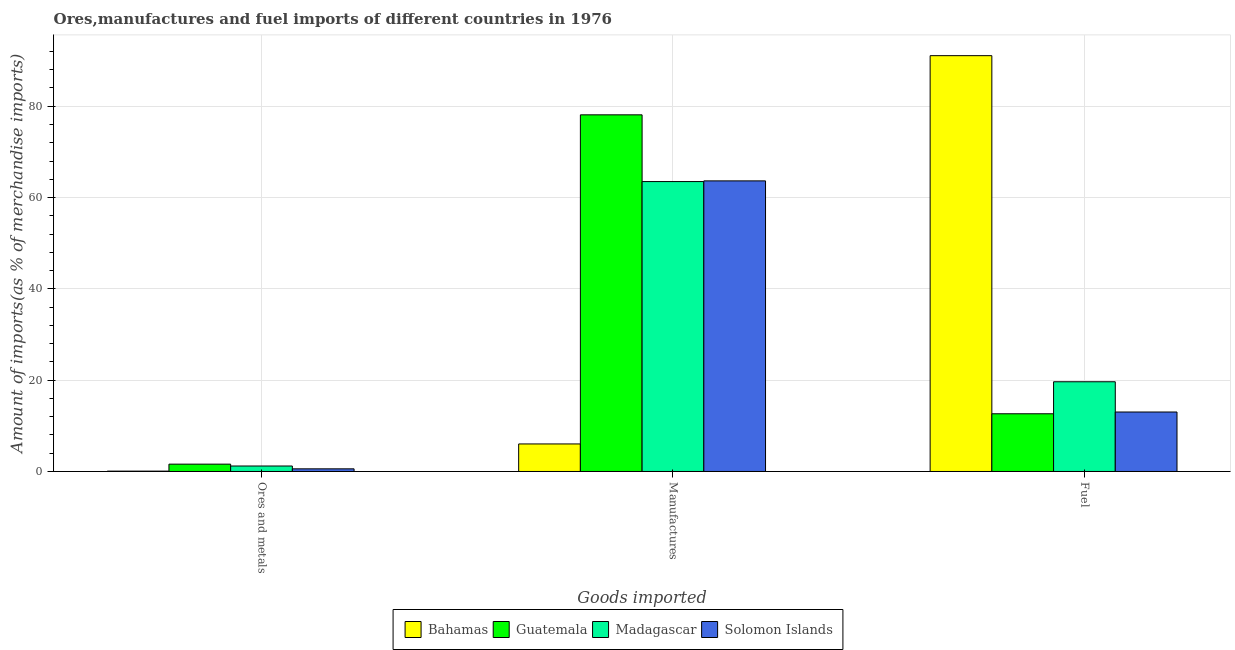How many groups of bars are there?
Make the answer very short. 3. Are the number of bars on each tick of the X-axis equal?
Your answer should be compact. Yes. What is the label of the 3rd group of bars from the left?
Make the answer very short. Fuel. What is the percentage of ores and metals imports in Solomon Islands?
Offer a terse response. 0.58. Across all countries, what is the maximum percentage of ores and metals imports?
Provide a succinct answer. 1.61. Across all countries, what is the minimum percentage of ores and metals imports?
Offer a terse response. 0.08. In which country was the percentage of ores and metals imports maximum?
Keep it short and to the point. Guatemala. In which country was the percentage of ores and metals imports minimum?
Give a very brief answer. Bahamas. What is the total percentage of ores and metals imports in the graph?
Make the answer very short. 3.46. What is the difference between the percentage of manufactures imports in Madagascar and that in Bahamas?
Provide a succinct answer. 57.47. What is the difference between the percentage of manufactures imports in Bahamas and the percentage of ores and metals imports in Madagascar?
Offer a terse response. 4.83. What is the average percentage of fuel imports per country?
Ensure brevity in your answer.  34.1. What is the difference between the percentage of ores and metals imports and percentage of manufactures imports in Guatemala?
Your response must be concise. -76.51. What is the ratio of the percentage of ores and metals imports in Guatemala to that in Madagascar?
Your response must be concise. 1.34. What is the difference between the highest and the second highest percentage of fuel imports?
Your response must be concise. 71.43. What is the difference between the highest and the lowest percentage of fuel imports?
Offer a terse response. 78.44. Is the sum of the percentage of ores and metals imports in Solomon Islands and Madagascar greater than the maximum percentage of manufactures imports across all countries?
Make the answer very short. No. What does the 2nd bar from the left in Manufactures represents?
Your answer should be compact. Guatemala. What does the 2nd bar from the right in Fuel represents?
Give a very brief answer. Madagascar. Is it the case that in every country, the sum of the percentage of ores and metals imports and percentage of manufactures imports is greater than the percentage of fuel imports?
Your response must be concise. No. How many bars are there?
Keep it short and to the point. 12. Are the values on the major ticks of Y-axis written in scientific E-notation?
Your answer should be very brief. No. Does the graph contain any zero values?
Provide a short and direct response. No. Where does the legend appear in the graph?
Give a very brief answer. Bottom center. How are the legend labels stacked?
Provide a short and direct response. Horizontal. What is the title of the graph?
Make the answer very short. Ores,manufactures and fuel imports of different countries in 1976. Does "Gabon" appear as one of the legend labels in the graph?
Make the answer very short. No. What is the label or title of the X-axis?
Keep it short and to the point. Goods imported. What is the label or title of the Y-axis?
Offer a very short reply. Amount of imports(as % of merchandise imports). What is the Amount of imports(as % of merchandise imports) in Bahamas in Ores and metals?
Provide a short and direct response. 0.08. What is the Amount of imports(as % of merchandise imports) of Guatemala in Ores and metals?
Give a very brief answer. 1.61. What is the Amount of imports(as % of merchandise imports) of Madagascar in Ores and metals?
Make the answer very short. 1.2. What is the Amount of imports(as % of merchandise imports) of Solomon Islands in Ores and metals?
Your answer should be very brief. 0.58. What is the Amount of imports(as % of merchandise imports) of Bahamas in Manufactures?
Keep it short and to the point. 6.03. What is the Amount of imports(as % of merchandise imports) in Guatemala in Manufactures?
Provide a succinct answer. 78.12. What is the Amount of imports(as % of merchandise imports) of Madagascar in Manufactures?
Make the answer very short. 63.5. What is the Amount of imports(as % of merchandise imports) of Solomon Islands in Manufactures?
Your answer should be very brief. 63.65. What is the Amount of imports(as % of merchandise imports) in Bahamas in Fuel?
Your response must be concise. 91.08. What is the Amount of imports(as % of merchandise imports) of Guatemala in Fuel?
Provide a short and direct response. 12.64. What is the Amount of imports(as % of merchandise imports) in Madagascar in Fuel?
Make the answer very short. 19.65. What is the Amount of imports(as % of merchandise imports) of Solomon Islands in Fuel?
Your answer should be very brief. 13.03. Across all Goods imported, what is the maximum Amount of imports(as % of merchandise imports) in Bahamas?
Your answer should be compact. 91.08. Across all Goods imported, what is the maximum Amount of imports(as % of merchandise imports) of Guatemala?
Keep it short and to the point. 78.12. Across all Goods imported, what is the maximum Amount of imports(as % of merchandise imports) of Madagascar?
Your response must be concise. 63.5. Across all Goods imported, what is the maximum Amount of imports(as % of merchandise imports) of Solomon Islands?
Offer a terse response. 63.65. Across all Goods imported, what is the minimum Amount of imports(as % of merchandise imports) of Bahamas?
Keep it short and to the point. 0.08. Across all Goods imported, what is the minimum Amount of imports(as % of merchandise imports) in Guatemala?
Offer a terse response. 1.61. Across all Goods imported, what is the minimum Amount of imports(as % of merchandise imports) of Madagascar?
Provide a short and direct response. 1.2. Across all Goods imported, what is the minimum Amount of imports(as % of merchandise imports) of Solomon Islands?
Ensure brevity in your answer.  0.58. What is the total Amount of imports(as % of merchandise imports) in Bahamas in the graph?
Provide a short and direct response. 97.19. What is the total Amount of imports(as % of merchandise imports) in Guatemala in the graph?
Your answer should be compact. 92.36. What is the total Amount of imports(as % of merchandise imports) in Madagascar in the graph?
Offer a terse response. 84.35. What is the total Amount of imports(as % of merchandise imports) of Solomon Islands in the graph?
Ensure brevity in your answer.  77.26. What is the difference between the Amount of imports(as % of merchandise imports) in Bahamas in Ores and metals and that in Manufactures?
Your response must be concise. -5.95. What is the difference between the Amount of imports(as % of merchandise imports) of Guatemala in Ores and metals and that in Manufactures?
Provide a succinct answer. -76.51. What is the difference between the Amount of imports(as % of merchandise imports) of Madagascar in Ores and metals and that in Manufactures?
Ensure brevity in your answer.  -62.3. What is the difference between the Amount of imports(as % of merchandise imports) in Solomon Islands in Ores and metals and that in Manufactures?
Provide a succinct answer. -63.07. What is the difference between the Amount of imports(as % of merchandise imports) in Bahamas in Ores and metals and that in Fuel?
Your answer should be very brief. -91. What is the difference between the Amount of imports(as % of merchandise imports) in Guatemala in Ores and metals and that in Fuel?
Your response must be concise. -11.03. What is the difference between the Amount of imports(as % of merchandise imports) in Madagascar in Ores and metals and that in Fuel?
Your answer should be very brief. -18.45. What is the difference between the Amount of imports(as % of merchandise imports) in Solomon Islands in Ores and metals and that in Fuel?
Give a very brief answer. -12.45. What is the difference between the Amount of imports(as % of merchandise imports) of Bahamas in Manufactures and that in Fuel?
Ensure brevity in your answer.  -85.05. What is the difference between the Amount of imports(as % of merchandise imports) in Guatemala in Manufactures and that in Fuel?
Your response must be concise. 65.48. What is the difference between the Amount of imports(as % of merchandise imports) of Madagascar in Manufactures and that in Fuel?
Offer a very short reply. 43.85. What is the difference between the Amount of imports(as % of merchandise imports) in Solomon Islands in Manufactures and that in Fuel?
Make the answer very short. 50.63. What is the difference between the Amount of imports(as % of merchandise imports) of Bahamas in Ores and metals and the Amount of imports(as % of merchandise imports) of Guatemala in Manufactures?
Offer a very short reply. -78.04. What is the difference between the Amount of imports(as % of merchandise imports) of Bahamas in Ores and metals and the Amount of imports(as % of merchandise imports) of Madagascar in Manufactures?
Offer a terse response. -63.42. What is the difference between the Amount of imports(as % of merchandise imports) in Bahamas in Ores and metals and the Amount of imports(as % of merchandise imports) in Solomon Islands in Manufactures?
Provide a succinct answer. -63.57. What is the difference between the Amount of imports(as % of merchandise imports) in Guatemala in Ores and metals and the Amount of imports(as % of merchandise imports) in Madagascar in Manufactures?
Give a very brief answer. -61.9. What is the difference between the Amount of imports(as % of merchandise imports) of Guatemala in Ores and metals and the Amount of imports(as % of merchandise imports) of Solomon Islands in Manufactures?
Your response must be concise. -62.05. What is the difference between the Amount of imports(as % of merchandise imports) of Madagascar in Ores and metals and the Amount of imports(as % of merchandise imports) of Solomon Islands in Manufactures?
Make the answer very short. -62.45. What is the difference between the Amount of imports(as % of merchandise imports) of Bahamas in Ores and metals and the Amount of imports(as % of merchandise imports) of Guatemala in Fuel?
Offer a very short reply. -12.56. What is the difference between the Amount of imports(as % of merchandise imports) of Bahamas in Ores and metals and the Amount of imports(as % of merchandise imports) of Madagascar in Fuel?
Keep it short and to the point. -19.57. What is the difference between the Amount of imports(as % of merchandise imports) of Bahamas in Ores and metals and the Amount of imports(as % of merchandise imports) of Solomon Islands in Fuel?
Provide a short and direct response. -12.95. What is the difference between the Amount of imports(as % of merchandise imports) in Guatemala in Ores and metals and the Amount of imports(as % of merchandise imports) in Madagascar in Fuel?
Provide a succinct answer. -18.05. What is the difference between the Amount of imports(as % of merchandise imports) in Guatemala in Ores and metals and the Amount of imports(as % of merchandise imports) in Solomon Islands in Fuel?
Offer a very short reply. -11.42. What is the difference between the Amount of imports(as % of merchandise imports) in Madagascar in Ores and metals and the Amount of imports(as % of merchandise imports) in Solomon Islands in Fuel?
Give a very brief answer. -11.83. What is the difference between the Amount of imports(as % of merchandise imports) in Bahamas in Manufactures and the Amount of imports(as % of merchandise imports) in Guatemala in Fuel?
Your response must be concise. -6.61. What is the difference between the Amount of imports(as % of merchandise imports) in Bahamas in Manufactures and the Amount of imports(as % of merchandise imports) in Madagascar in Fuel?
Offer a very short reply. -13.62. What is the difference between the Amount of imports(as % of merchandise imports) in Bahamas in Manufactures and the Amount of imports(as % of merchandise imports) in Solomon Islands in Fuel?
Ensure brevity in your answer.  -6.99. What is the difference between the Amount of imports(as % of merchandise imports) of Guatemala in Manufactures and the Amount of imports(as % of merchandise imports) of Madagascar in Fuel?
Offer a terse response. 58.46. What is the difference between the Amount of imports(as % of merchandise imports) in Guatemala in Manufactures and the Amount of imports(as % of merchandise imports) in Solomon Islands in Fuel?
Your answer should be compact. 65.09. What is the difference between the Amount of imports(as % of merchandise imports) in Madagascar in Manufactures and the Amount of imports(as % of merchandise imports) in Solomon Islands in Fuel?
Give a very brief answer. 50.48. What is the average Amount of imports(as % of merchandise imports) in Bahamas per Goods imported?
Make the answer very short. 32.4. What is the average Amount of imports(as % of merchandise imports) in Guatemala per Goods imported?
Your response must be concise. 30.79. What is the average Amount of imports(as % of merchandise imports) of Madagascar per Goods imported?
Make the answer very short. 28.12. What is the average Amount of imports(as % of merchandise imports) of Solomon Islands per Goods imported?
Offer a terse response. 25.75. What is the difference between the Amount of imports(as % of merchandise imports) of Bahamas and Amount of imports(as % of merchandise imports) of Guatemala in Ores and metals?
Provide a succinct answer. -1.53. What is the difference between the Amount of imports(as % of merchandise imports) in Bahamas and Amount of imports(as % of merchandise imports) in Madagascar in Ores and metals?
Make the answer very short. -1.12. What is the difference between the Amount of imports(as % of merchandise imports) of Bahamas and Amount of imports(as % of merchandise imports) of Solomon Islands in Ores and metals?
Provide a succinct answer. -0.5. What is the difference between the Amount of imports(as % of merchandise imports) of Guatemala and Amount of imports(as % of merchandise imports) of Madagascar in Ores and metals?
Make the answer very short. 0.41. What is the difference between the Amount of imports(as % of merchandise imports) of Guatemala and Amount of imports(as % of merchandise imports) of Solomon Islands in Ores and metals?
Offer a terse response. 1.03. What is the difference between the Amount of imports(as % of merchandise imports) of Madagascar and Amount of imports(as % of merchandise imports) of Solomon Islands in Ores and metals?
Keep it short and to the point. 0.62. What is the difference between the Amount of imports(as % of merchandise imports) in Bahamas and Amount of imports(as % of merchandise imports) in Guatemala in Manufactures?
Your answer should be compact. -72.08. What is the difference between the Amount of imports(as % of merchandise imports) of Bahamas and Amount of imports(as % of merchandise imports) of Madagascar in Manufactures?
Your response must be concise. -57.47. What is the difference between the Amount of imports(as % of merchandise imports) of Bahamas and Amount of imports(as % of merchandise imports) of Solomon Islands in Manufactures?
Keep it short and to the point. -57.62. What is the difference between the Amount of imports(as % of merchandise imports) of Guatemala and Amount of imports(as % of merchandise imports) of Madagascar in Manufactures?
Your response must be concise. 14.61. What is the difference between the Amount of imports(as % of merchandise imports) of Guatemala and Amount of imports(as % of merchandise imports) of Solomon Islands in Manufactures?
Provide a short and direct response. 14.46. What is the difference between the Amount of imports(as % of merchandise imports) of Madagascar and Amount of imports(as % of merchandise imports) of Solomon Islands in Manufactures?
Keep it short and to the point. -0.15. What is the difference between the Amount of imports(as % of merchandise imports) in Bahamas and Amount of imports(as % of merchandise imports) in Guatemala in Fuel?
Your answer should be very brief. 78.44. What is the difference between the Amount of imports(as % of merchandise imports) in Bahamas and Amount of imports(as % of merchandise imports) in Madagascar in Fuel?
Provide a succinct answer. 71.43. What is the difference between the Amount of imports(as % of merchandise imports) of Bahamas and Amount of imports(as % of merchandise imports) of Solomon Islands in Fuel?
Your answer should be very brief. 78.05. What is the difference between the Amount of imports(as % of merchandise imports) in Guatemala and Amount of imports(as % of merchandise imports) in Madagascar in Fuel?
Provide a short and direct response. -7.01. What is the difference between the Amount of imports(as % of merchandise imports) in Guatemala and Amount of imports(as % of merchandise imports) in Solomon Islands in Fuel?
Offer a terse response. -0.39. What is the difference between the Amount of imports(as % of merchandise imports) in Madagascar and Amount of imports(as % of merchandise imports) in Solomon Islands in Fuel?
Give a very brief answer. 6.63. What is the ratio of the Amount of imports(as % of merchandise imports) of Bahamas in Ores and metals to that in Manufactures?
Offer a very short reply. 0.01. What is the ratio of the Amount of imports(as % of merchandise imports) of Guatemala in Ores and metals to that in Manufactures?
Your answer should be very brief. 0.02. What is the ratio of the Amount of imports(as % of merchandise imports) of Madagascar in Ores and metals to that in Manufactures?
Your answer should be very brief. 0.02. What is the ratio of the Amount of imports(as % of merchandise imports) in Solomon Islands in Ores and metals to that in Manufactures?
Your answer should be compact. 0.01. What is the ratio of the Amount of imports(as % of merchandise imports) in Bahamas in Ores and metals to that in Fuel?
Keep it short and to the point. 0. What is the ratio of the Amount of imports(as % of merchandise imports) in Guatemala in Ores and metals to that in Fuel?
Provide a short and direct response. 0.13. What is the ratio of the Amount of imports(as % of merchandise imports) of Madagascar in Ores and metals to that in Fuel?
Your response must be concise. 0.06. What is the ratio of the Amount of imports(as % of merchandise imports) of Solomon Islands in Ores and metals to that in Fuel?
Give a very brief answer. 0.04. What is the ratio of the Amount of imports(as % of merchandise imports) in Bahamas in Manufactures to that in Fuel?
Keep it short and to the point. 0.07. What is the ratio of the Amount of imports(as % of merchandise imports) of Guatemala in Manufactures to that in Fuel?
Offer a terse response. 6.18. What is the ratio of the Amount of imports(as % of merchandise imports) in Madagascar in Manufactures to that in Fuel?
Keep it short and to the point. 3.23. What is the ratio of the Amount of imports(as % of merchandise imports) in Solomon Islands in Manufactures to that in Fuel?
Make the answer very short. 4.89. What is the difference between the highest and the second highest Amount of imports(as % of merchandise imports) of Bahamas?
Your response must be concise. 85.05. What is the difference between the highest and the second highest Amount of imports(as % of merchandise imports) of Guatemala?
Give a very brief answer. 65.48. What is the difference between the highest and the second highest Amount of imports(as % of merchandise imports) of Madagascar?
Keep it short and to the point. 43.85. What is the difference between the highest and the second highest Amount of imports(as % of merchandise imports) in Solomon Islands?
Your response must be concise. 50.63. What is the difference between the highest and the lowest Amount of imports(as % of merchandise imports) in Bahamas?
Your response must be concise. 91. What is the difference between the highest and the lowest Amount of imports(as % of merchandise imports) in Guatemala?
Your answer should be very brief. 76.51. What is the difference between the highest and the lowest Amount of imports(as % of merchandise imports) in Madagascar?
Offer a terse response. 62.3. What is the difference between the highest and the lowest Amount of imports(as % of merchandise imports) of Solomon Islands?
Give a very brief answer. 63.07. 